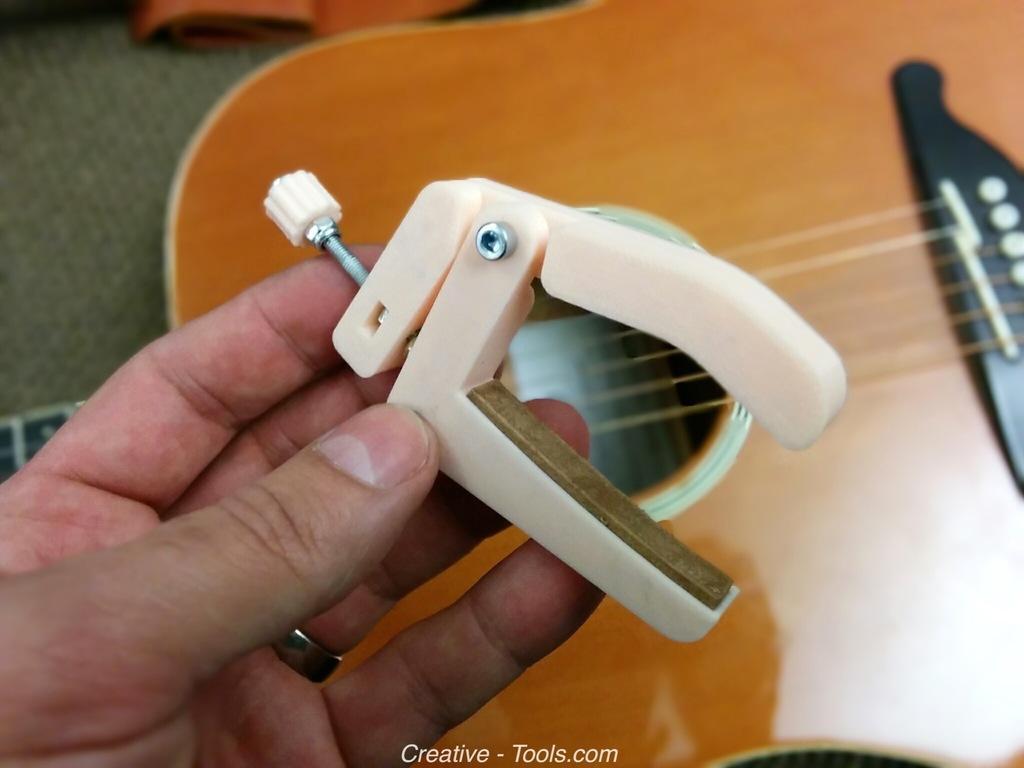In one or two sentences, can you explain what this image depicts? The image consists of a guitar and a hand with a guitar tuner in it. 